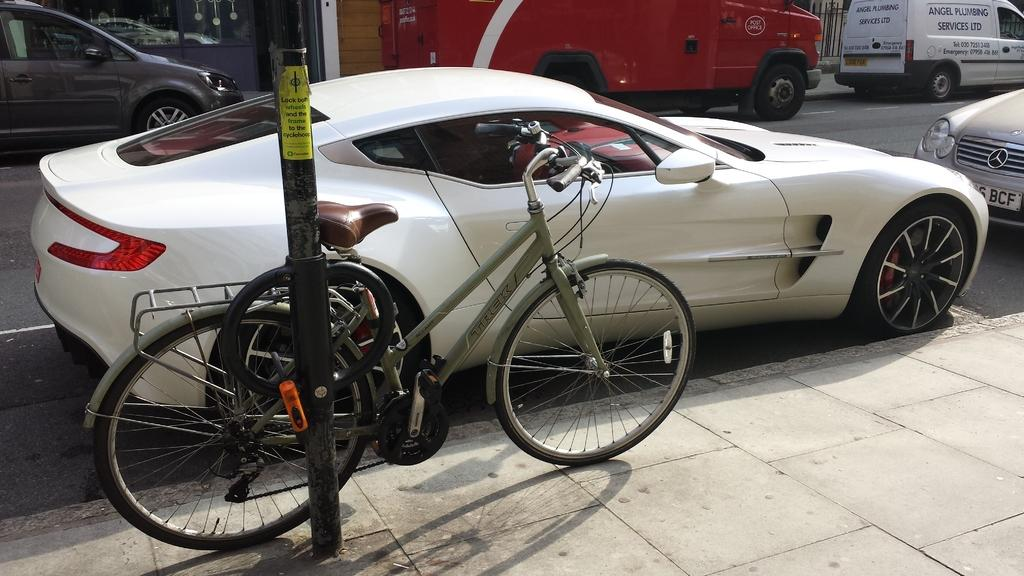What is located in the front of the image? There is a pole in the front of the image. What can be seen in the center of the image? There is a bicycle in the center of the image. What is visible in the background of the image? There are cars and buildings in the background of the image. How many lizards are sitting on the bicycle in the image? There are no lizards present in the image. Is there a bridge visible in the background of the image? No, there is no bridge visible in the image; only cars and buildings can be seen in the background. 